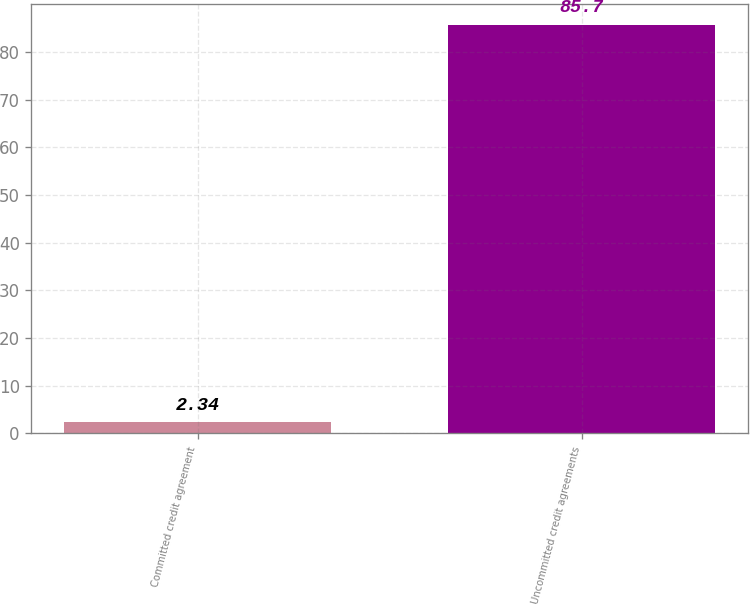<chart> <loc_0><loc_0><loc_500><loc_500><bar_chart><fcel>Committed credit agreement<fcel>Uncommitted credit agreements<nl><fcel>2.34<fcel>85.7<nl></chart> 